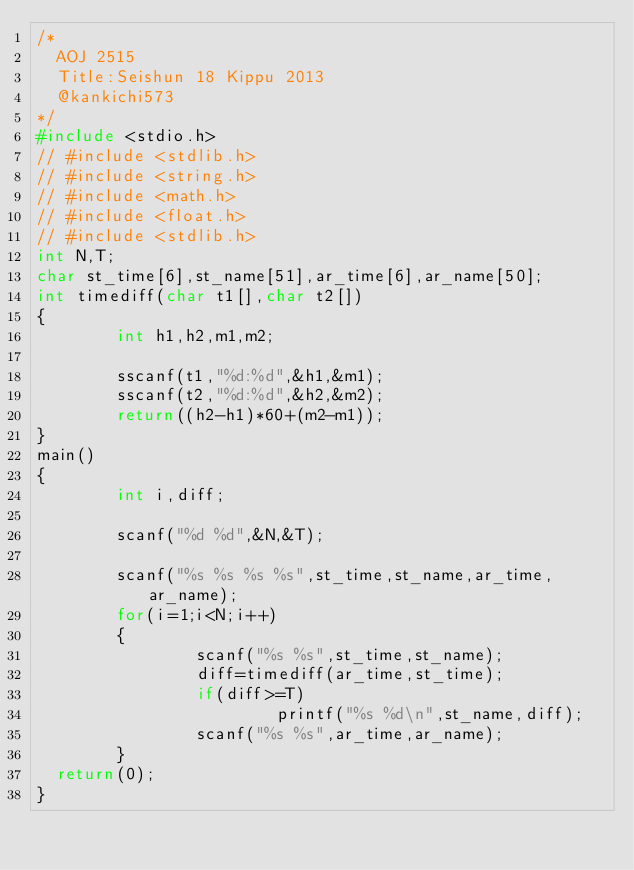Convert code to text. <code><loc_0><loc_0><loc_500><loc_500><_C_>/*
  AOJ 2515
  Title:Seishun 18 Kippu 2013
  @kankichi573
*/
#include <stdio.h>
// #include <stdlib.h>
// #include <string.h>
// #include <math.h>
// #include <float.h>
// #include <stdlib.h>
int N,T;
char st_time[6],st_name[51],ar_time[6],ar_name[50];
int timediff(char t1[],char t2[])
{
        int h1,h2,m1,m2;

        sscanf(t1,"%d:%d",&h1,&m1);
        sscanf(t2,"%d:%d",&h2,&m2);
        return((h2-h1)*60+(m2-m1));
}
main()
{
        int i,diff;

        scanf("%d %d",&N,&T);

        scanf("%s %s %s %s",st_time,st_name,ar_time,ar_name);
        for(i=1;i<N;i++)
        {
                scanf("%s %s",st_time,st_name);
                diff=timediff(ar_time,st_time);
                if(diff>=T)
                        printf("%s %d\n",st_name,diff);
                scanf("%s %s",ar_time,ar_name);
        }
  return(0);
}</code> 